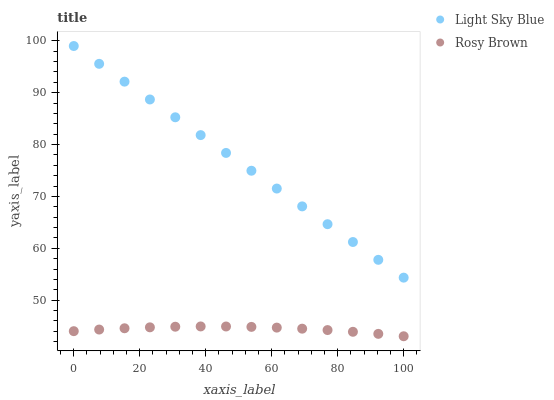Does Rosy Brown have the minimum area under the curve?
Answer yes or no. Yes. Does Light Sky Blue have the maximum area under the curve?
Answer yes or no. Yes. Does Light Sky Blue have the minimum area under the curve?
Answer yes or no. No. Is Light Sky Blue the smoothest?
Answer yes or no. Yes. Is Rosy Brown the roughest?
Answer yes or no. Yes. Is Light Sky Blue the roughest?
Answer yes or no. No. Does Rosy Brown have the lowest value?
Answer yes or no. Yes. Does Light Sky Blue have the lowest value?
Answer yes or no. No. Does Light Sky Blue have the highest value?
Answer yes or no. Yes. Is Rosy Brown less than Light Sky Blue?
Answer yes or no. Yes. Is Light Sky Blue greater than Rosy Brown?
Answer yes or no. Yes. Does Rosy Brown intersect Light Sky Blue?
Answer yes or no. No. 